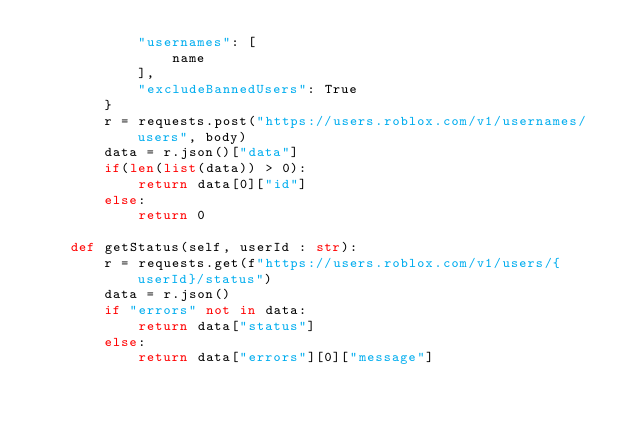Convert code to text. <code><loc_0><loc_0><loc_500><loc_500><_Python_>            "usernames": [
                name
            ],
            "excludeBannedUsers": True
        }
        r = requests.post("https://users.roblox.com/v1/usernames/users", body)
        data = r.json()["data"]
        if(len(list(data)) > 0):
            return data[0]["id"]
        else:
            return 0

    def getStatus(self, userId : str):
        r = requests.get(f"https://users.roblox.com/v1/users/{userId}/status")
        data = r.json()
        if "errors" not in data:
            return data["status"]
        else:
            return data["errors"][0]["message"]</code> 